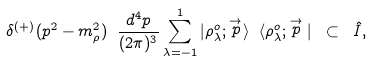<formula> <loc_0><loc_0><loc_500><loc_500>\delta ^ { ( + ) } ( p ^ { 2 } - m _ { \rho } ^ { 2 } ) \ \frac { d ^ { 4 } p } { ( 2 \pi ) ^ { 3 } } \sum _ { \lambda = - 1 } ^ { 1 } | \rho ^ { o } _ { \lambda } ; \stackrel { \rightarrow } { p } \rangle \ \langle \rho ^ { o } _ { \lambda } ; \stackrel { \rightarrow } { p } | \ \subset \ { \hat { I } } ,</formula> 